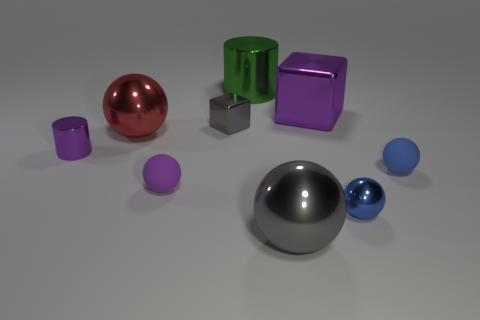Subtract all big metal balls. How many balls are left? 3 Add 1 small blue spheres. How many objects exist? 10 Subtract all cyan cylinders. How many blue spheres are left? 2 Subtract all purple cylinders. How many cylinders are left? 1 Subtract 3 balls. How many balls are left? 2 Subtract all spheres. How many objects are left? 4 Subtract all green blocks. Subtract all gray spheres. How many blocks are left? 2 Subtract all purple matte spheres. Subtract all purple shiny objects. How many objects are left? 6 Add 9 small purple metallic things. How many small purple metallic things are left? 10 Add 9 small gray things. How many small gray things exist? 10 